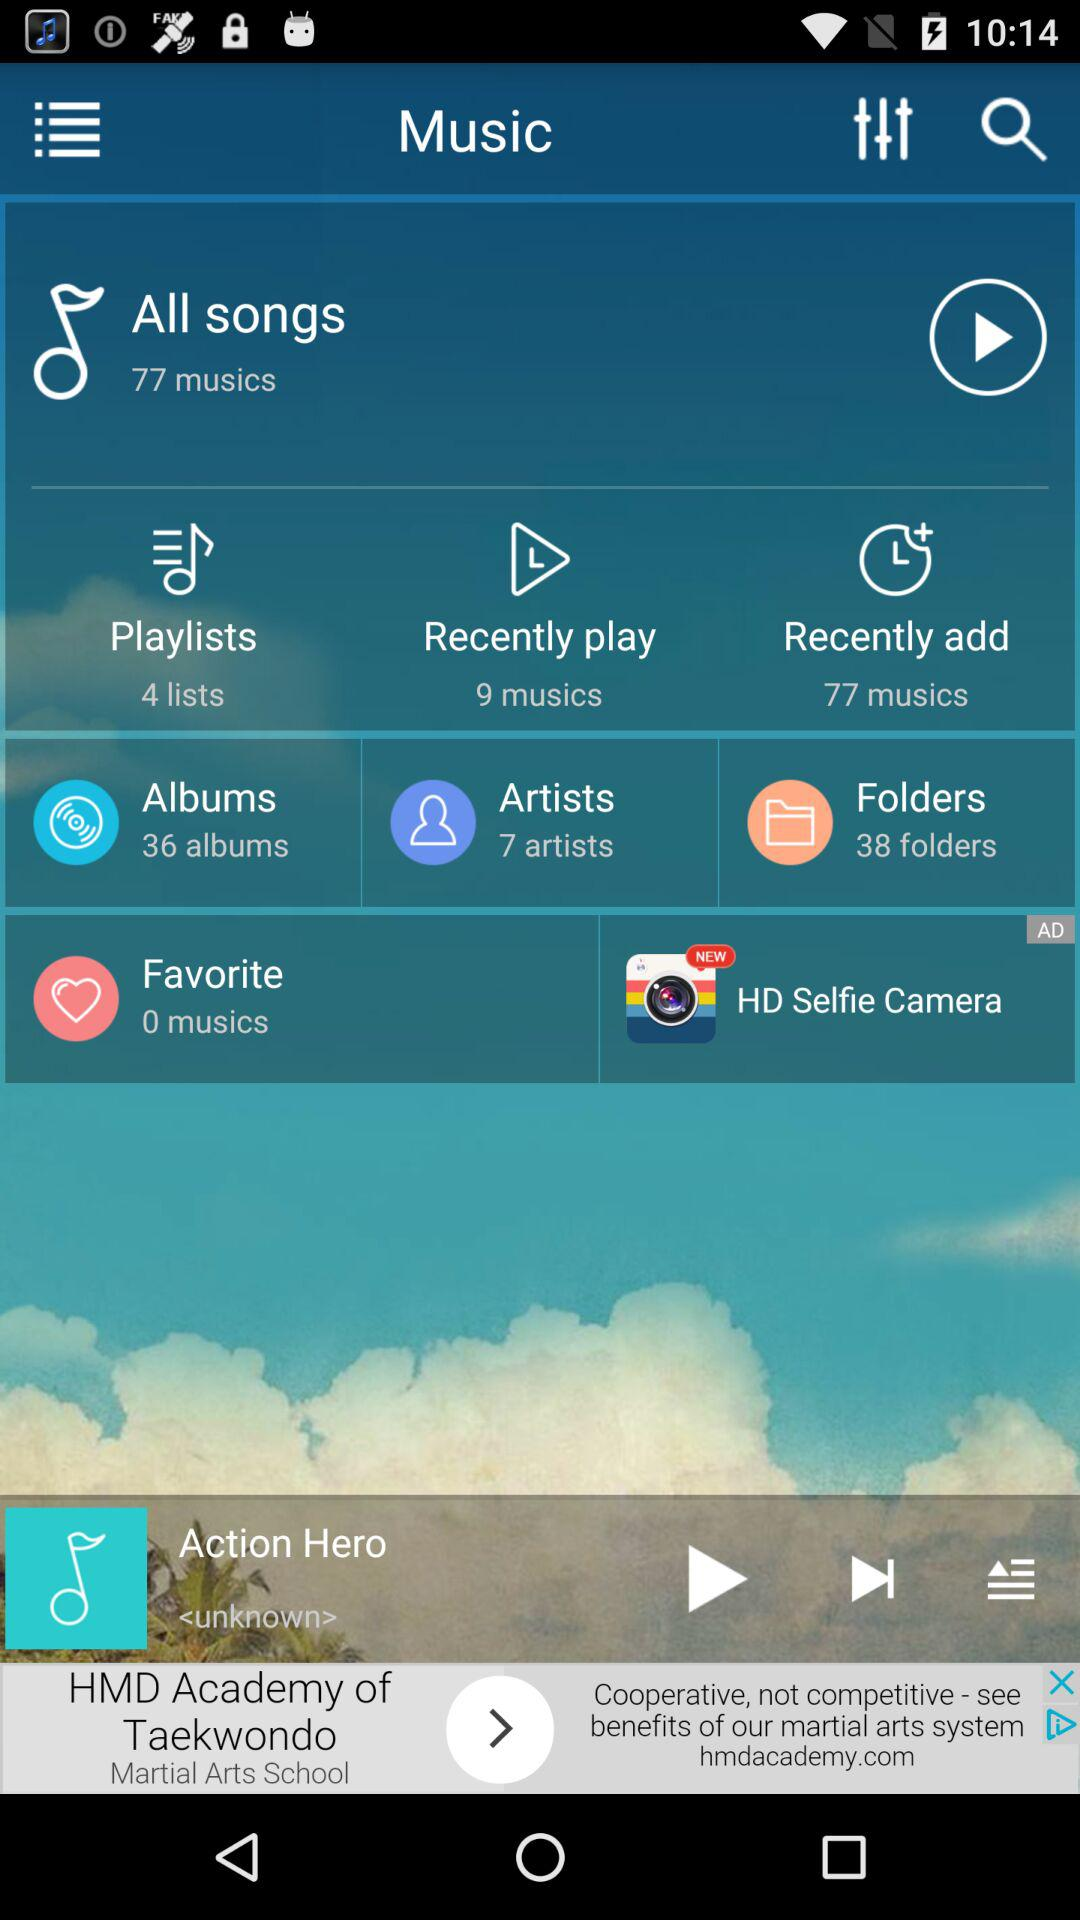How many more folders are there than artists?
Answer the question using a single word or phrase. 31 